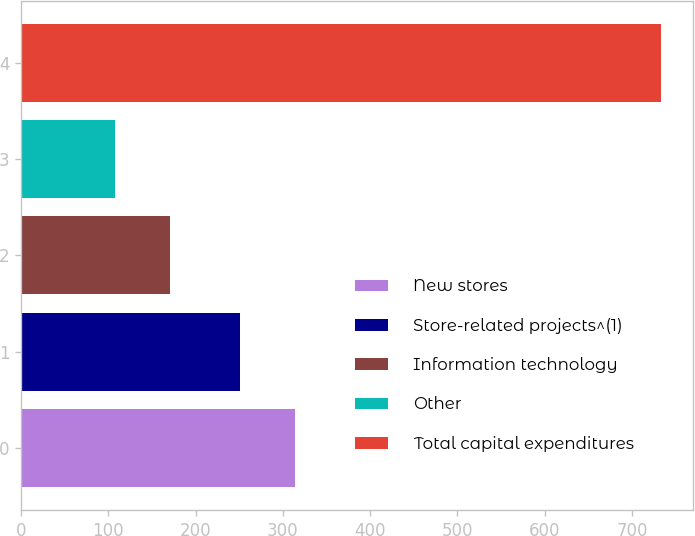Convert chart to OTSL. <chart><loc_0><loc_0><loc_500><loc_500><bar_chart><fcel>New stores<fcel>Store-related projects^(1)<fcel>Information technology<fcel>Other<fcel>Total capital expenditures<nl><fcel>313.5<fcel>251<fcel>170.5<fcel>108<fcel>733<nl></chart> 